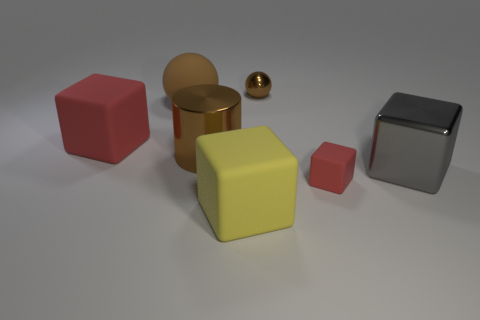Are there fewer large cylinders that are left of the brown metal cylinder than large blocks that are to the right of the large red cube? Upon examining the image, it appears there is one large cylinder to the left of the brown metal cylinder. To the right of the large red cube, there is one large block. Therefore, the quantities are equal, not fewer, which makes the original response of 'yes' technically incorrect. For accurate assessment, we need to meticulously count and compare the shapes as specified in the question. 